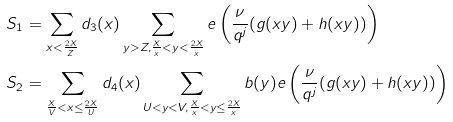<formula> <loc_0><loc_0><loc_500><loc_500>S _ { 1 } & = \sum _ { x < \frac { 2 X } { Z } } d _ { 3 } ( x ) \sum _ { y > Z , \frac { X } { x } < y < \frac { 2 X } { x } } e \left ( \frac { \nu } { q ^ { j } } ( g ( x y ) + h ( x y ) ) \right ) \\ S _ { 2 } & = \sum _ { \frac { X } { V } < x \leq \frac { 2 X } U } d _ { 4 } ( x ) \sum _ { U < y < V , \frac { X } { x } < y \leq \frac { 2 X } { x } } b ( y ) e \left ( \frac { \nu } { q ^ { j } } ( g ( x y ) + h ( x y ) ) \right )</formula> 